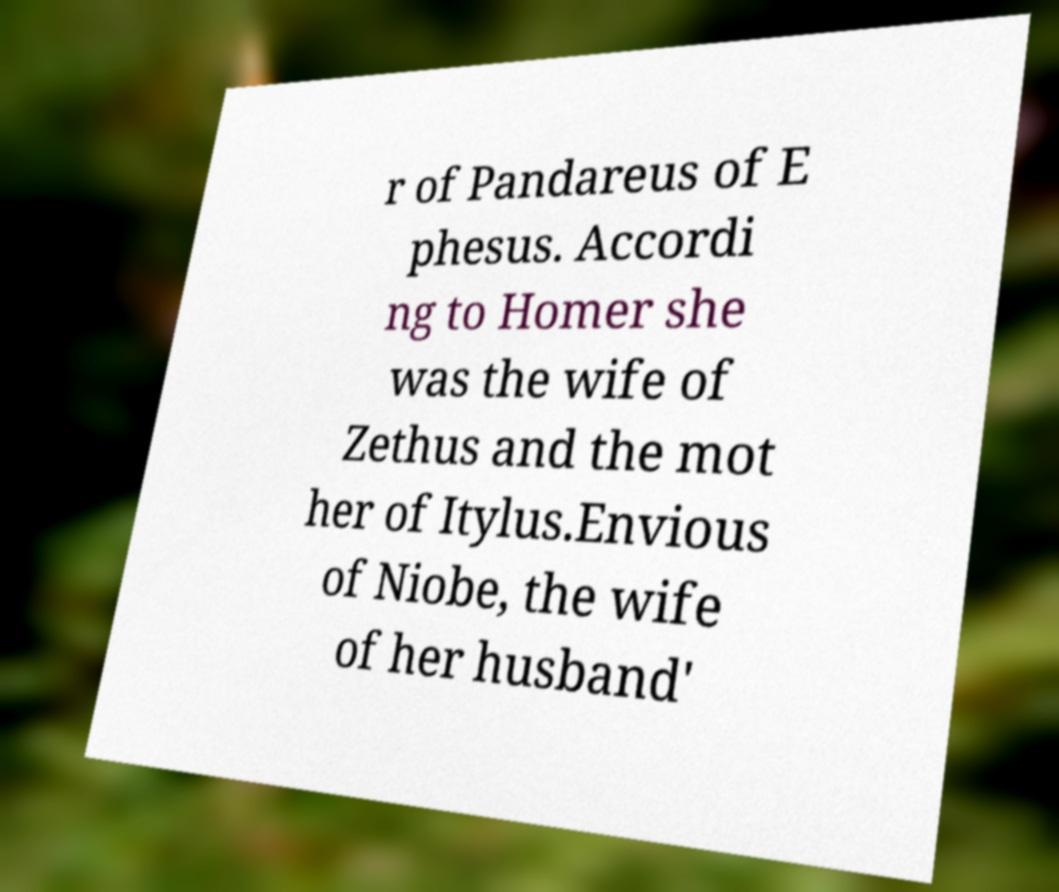For documentation purposes, I need the text within this image transcribed. Could you provide that? r of Pandareus of E phesus. Accordi ng to Homer she was the wife of Zethus and the mot her of Itylus.Envious of Niobe, the wife of her husband' 